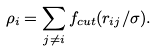<formula> <loc_0><loc_0><loc_500><loc_500>\rho _ { i } = \sum _ { j \neq i } f _ { c u t } ( r _ { i j } / \sigma ) .</formula> 